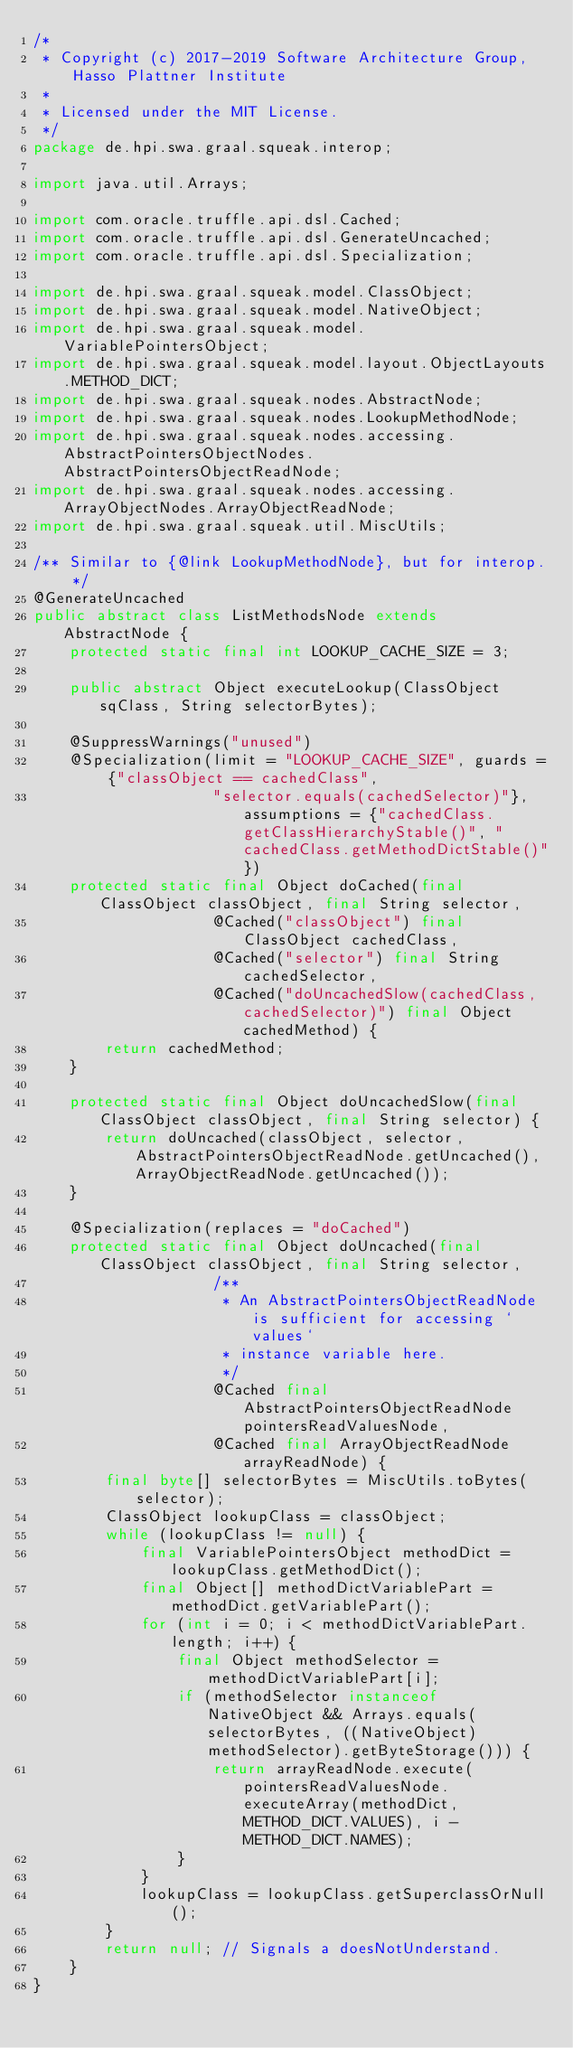<code> <loc_0><loc_0><loc_500><loc_500><_Java_>/*
 * Copyright (c) 2017-2019 Software Architecture Group, Hasso Plattner Institute
 *
 * Licensed under the MIT License.
 */
package de.hpi.swa.graal.squeak.interop;

import java.util.Arrays;

import com.oracle.truffle.api.dsl.Cached;
import com.oracle.truffle.api.dsl.GenerateUncached;
import com.oracle.truffle.api.dsl.Specialization;

import de.hpi.swa.graal.squeak.model.ClassObject;
import de.hpi.swa.graal.squeak.model.NativeObject;
import de.hpi.swa.graal.squeak.model.VariablePointersObject;
import de.hpi.swa.graal.squeak.model.layout.ObjectLayouts.METHOD_DICT;
import de.hpi.swa.graal.squeak.nodes.AbstractNode;
import de.hpi.swa.graal.squeak.nodes.LookupMethodNode;
import de.hpi.swa.graal.squeak.nodes.accessing.AbstractPointersObjectNodes.AbstractPointersObjectReadNode;
import de.hpi.swa.graal.squeak.nodes.accessing.ArrayObjectNodes.ArrayObjectReadNode;
import de.hpi.swa.graal.squeak.util.MiscUtils;

/** Similar to {@link LookupMethodNode}, but for interop. */
@GenerateUncached
public abstract class ListMethodsNode extends AbstractNode {
    protected static final int LOOKUP_CACHE_SIZE = 3;

    public abstract Object executeLookup(ClassObject sqClass, String selectorBytes);

    @SuppressWarnings("unused")
    @Specialization(limit = "LOOKUP_CACHE_SIZE", guards = {"classObject == cachedClass",
                    "selector.equals(cachedSelector)"}, assumptions = {"cachedClass.getClassHierarchyStable()", "cachedClass.getMethodDictStable()"})
    protected static final Object doCached(final ClassObject classObject, final String selector,
                    @Cached("classObject") final ClassObject cachedClass,
                    @Cached("selector") final String cachedSelector,
                    @Cached("doUncachedSlow(cachedClass, cachedSelector)") final Object cachedMethod) {
        return cachedMethod;
    }

    protected static final Object doUncachedSlow(final ClassObject classObject, final String selector) {
        return doUncached(classObject, selector, AbstractPointersObjectReadNode.getUncached(), ArrayObjectReadNode.getUncached());
    }

    @Specialization(replaces = "doCached")
    protected static final Object doUncached(final ClassObject classObject, final String selector,
                    /**
                     * An AbstractPointersObjectReadNode is sufficient for accessing `values`
                     * instance variable here.
                     */
                    @Cached final AbstractPointersObjectReadNode pointersReadValuesNode,
                    @Cached final ArrayObjectReadNode arrayReadNode) {
        final byte[] selectorBytes = MiscUtils.toBytes(selector);
        ClassObject lookupClass = classObject;
        while (lookupClass != null) {
            final VariablePointersObject methodDict = lookupClass.getMethodDict();
            final Object[] methodDictVariablePart = methodDict.getVariablePart();
            for (int i = 0; i < methodDictVariablePart.length; i++) {
                final Object methodSelector = methodDictVariablePart[i];
                if (methodSelector instanceof NativeObject && Arrays.equals(selectorBytes, ((NativeObject) methodSelector).getByteStorage())) {
                    return arrayReadNode.execute(pointersReadValuesNode.executeArray(methodDict, METHOD_DICT.VALUES), i - METHOD_DICT.NAMES);
                }
            }
            lookupClass = lookupClass.getSuperclassOrNull();
        }
        return null; // Signals a doesNotUnderstand.
    }
}
</code> 